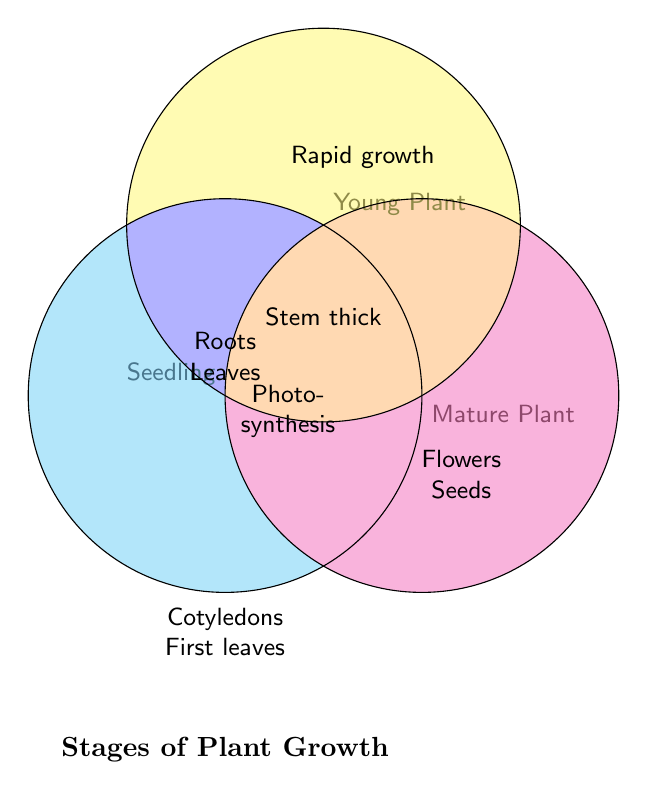What colors are used for the Seedling, Young Plant, and Mature Plant stages? The figure uses different colors to represent each stage: Seedling is represented by cyan, Young Plant by yellow, and Mature Plant by magenta.
Answer: Cyan, Yellow, Magenta What is the title of the Venn Diagram? Reading the text at the bottom of the Venn diagram, the title is "Stages of Plant Growth."
Answer: Stages of Plant Growth Where can you find the feature "Flowers blooming"? "Flowers blooming" is listed in the section labeled Mature Plant, which is represented by the magenta circle.
Answer: Mature Plant Which features are common to all three stages of plant growth? The section where all three circles overlap indicates that "Roots growing," "Leaves appearing," and "Photosynthesis active" are common to Seedling, Young Plant, and Mature Plant.
Answer: Roots growing, Leaves appearing, Photosynthesis active Where do you find "Rapid growth"? "Rapid growth" is found exclusively in the Young Plant section, which is represented by the yellow circle.
Answer: Young Plant Which stage has the unique feature of "Cotyledons visible"? "Cotyledons visible" is located only in the Seedling stage, which is represented by the cyan circle.
Answer: Seedling What features overlap between Seedling and Young Plant but not Mature Plant? The space where the cyan (Seedling) and yellow (Young Plant) circles overlap but do not intersect with the magenta (Mature Plant) shows "First true leaves" and "Stem thickening."
Answer: First true leaves, Stem thickening Which stage has features that do not overlap with either Seedling or Young Plant? The features that do not overlap with either Seedling or Young Plant but only belong to Mature Plant (magenta circle) are "Flowers blooming" and "Seeds forming."
Answer: Flowers blooming, Seeds forming How many features are unique to the Mature Plant stage? The Mature Plant stage has two unique features as indicated in the magenta circle's section only: "Flowers blooming" and "Seeds forming."
Answer: 2 